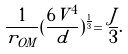<formula> <loc_0><loc_0><loc_500><loc_500>\frac { 1 } { r _ { O M } } ( \frac { 6 V ^ { 4 } } { d } ) ^ { \frac { 1 } { 3 } } = \frac { J } { 3 } .</formula> 